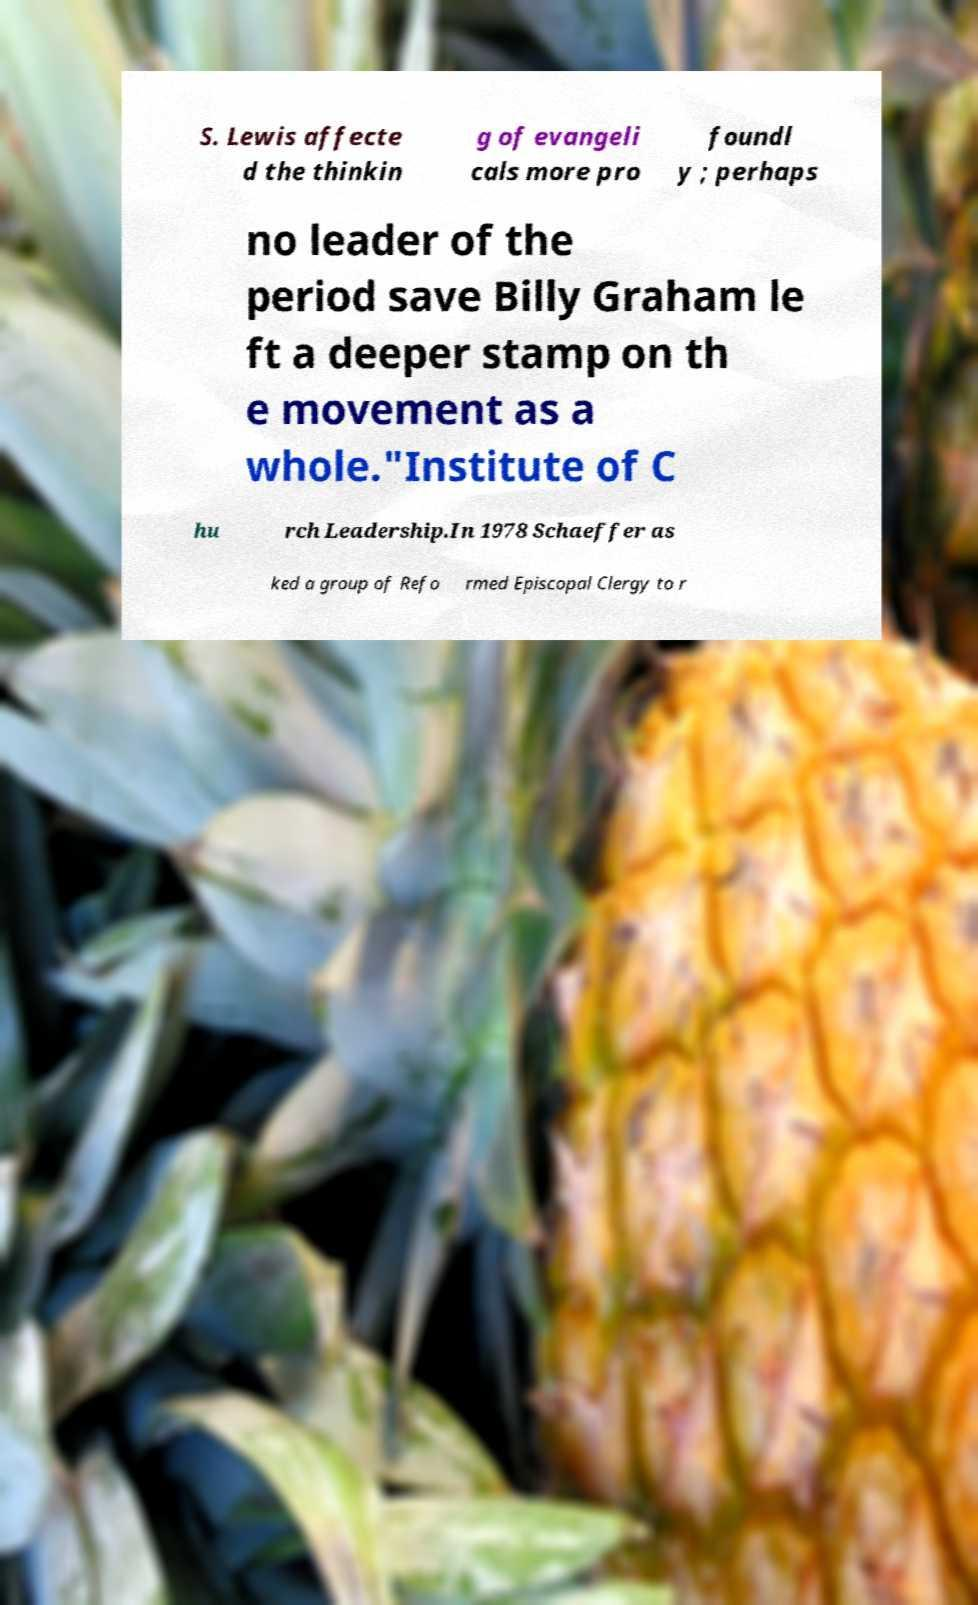Could you extract and type out the text from this image? S. Lewis affecte d the thinkin g of evangeli cals more pro foundl y ; perhaps no leader of the period save Billy Graham le ft a deeper stamp on th e movement as a whole."Institute of C hu rch Leadership.In 1978 Schaeffer as ked a group of Refo rmed Episcopal Clergy to r 